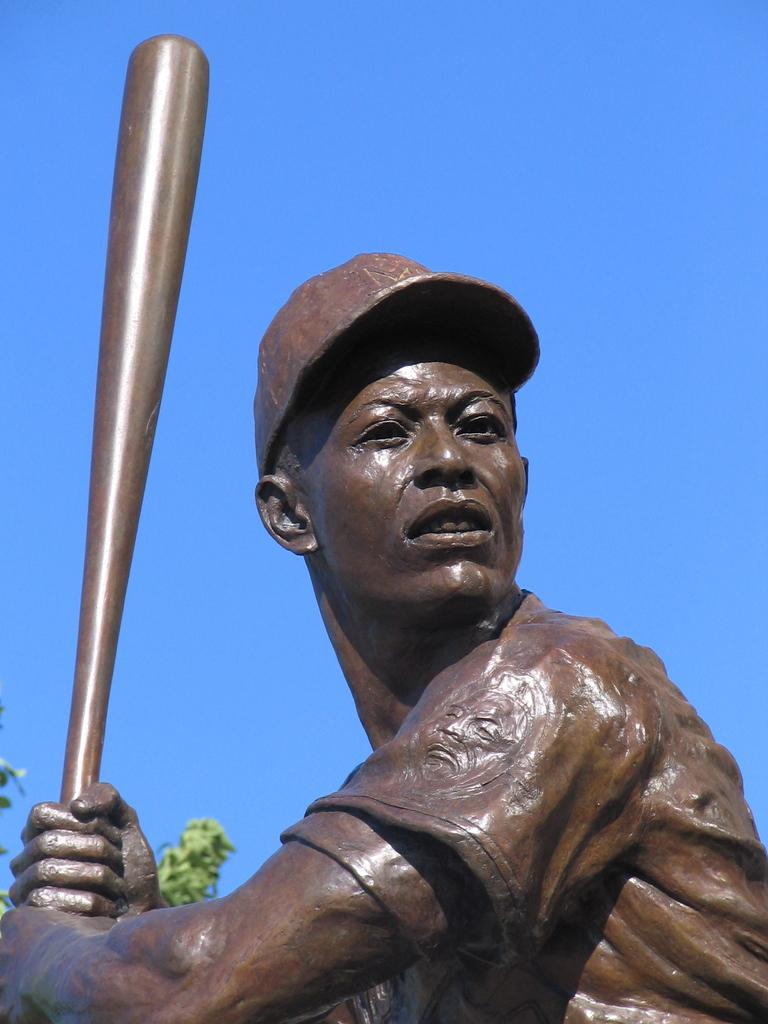What is the main subject of the image? There is a statue of a man in the image. What is the man holding in the image? The man is holding a baseball bat. What can be seen in the background of the image? The sky is visible in the image. Where is the coat located in the image? There is no coat present in the image. What type of home does the man live in, as depicted in the image? The image is of a statue, not a real person, so there is no home depicted in the image. 